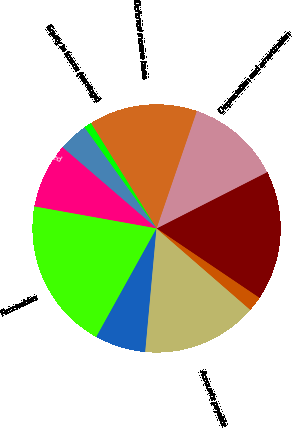Convert chart to OTSL. <chart><loc_0><loc_0><loc_500><loc_500><pie_chart><fcel>Net income<fcel>Depreciation and amortization<fcel>Deferred income taxes<fcel>Equity in losses (earnings)<fcel>Accrued pension and other<fcel>Contributions to qualified<fcel>Receivables<fcel>Other current assets<fcel>Accounts payable<fcel>Taxes accrued<nl><fcel>16.95%<fcel>12.25%<fcel>14.13%<fcel>0.99%<fcel>3.81%<fcel>8.5%<fcel>19.76%<fcel>6.62%<fcel>15.07%<fcel>1.93%<nl></chart> 